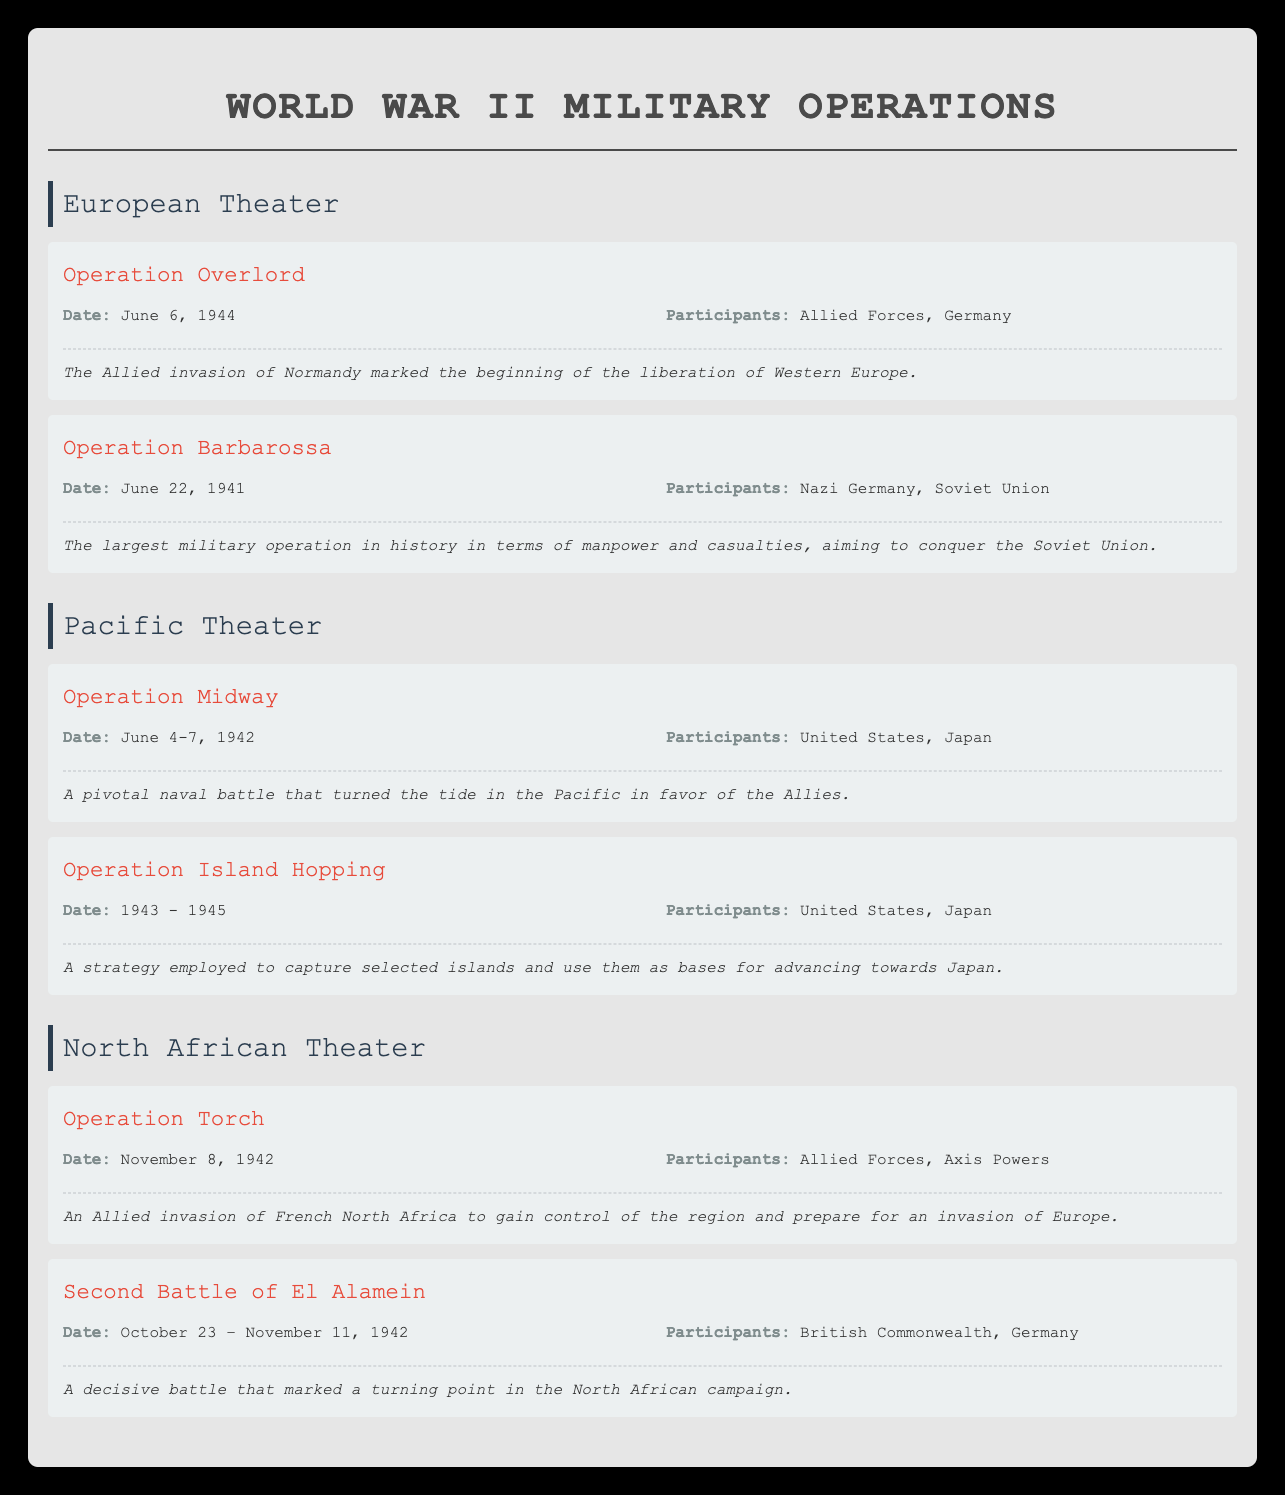What date did Operation Overlord take place? The table lists Operation Overlord under the European Theater, and specifies the date as June 6, 1944.
Answer: June 6, 1944 Which countries participated in Operation Barbarossa? In the table, Operation Barbarossa is mentioned with its participants listed as Nazi Germany and the Soviet Union.
Answer: Nazi Germany, Soviet Union Did the Pacific Theater include Operation Torch? The table does not list Operation Torch under the Pacific Theater; it instead appears in the North African Theater. Therefore, the answer is no.
Answer: No Which operation took place over the longest period? Comparing the start and end dates, Operation Island Hopping spans from 1943 to 1945. The other operations are singular events with specific dates. Thus, it has a duration of 2 years, which is longer than any other operation in the table.
Answer: Operation Island Hopping How many operations are listed under the North African Theater? The North African Theater includes two operations: Operation Torch and the Second Battle of El Alamein. Counting these gives a total of 2 operations listed.
Answer: 2 Was Operation Midway a land or naval battle? Operation Midway is described in the table as a pivotal naval battle. Hence, the answer to whether it was a land or naval battle is clear.
Answer: Naval battle Which operation had the most participants? In examining the operations, Operation Island Hopping includes the participants "United States, Japan," and the other operations have two participants only. Thus, Operation Island Hopping has the most participants, involving two nations.
Answer: Operation Island Hopping What was the primary goal of Operation Torch? The table indicates that Operation Torch aimed to gain control of French North Africa and prepare for an invasion of Europe. This goal clarifies the purpose of the operation.
Answer: Gain control of French North Africa, prepare for invasion of Europe Which operation is considered the largest in terms of manpower and casualties? According to the table, Operation Barbarossa is described as the largest military operation in history regarding manpower and casualties, indicating its significance and scale.
Answer: Operation Barbarossa 